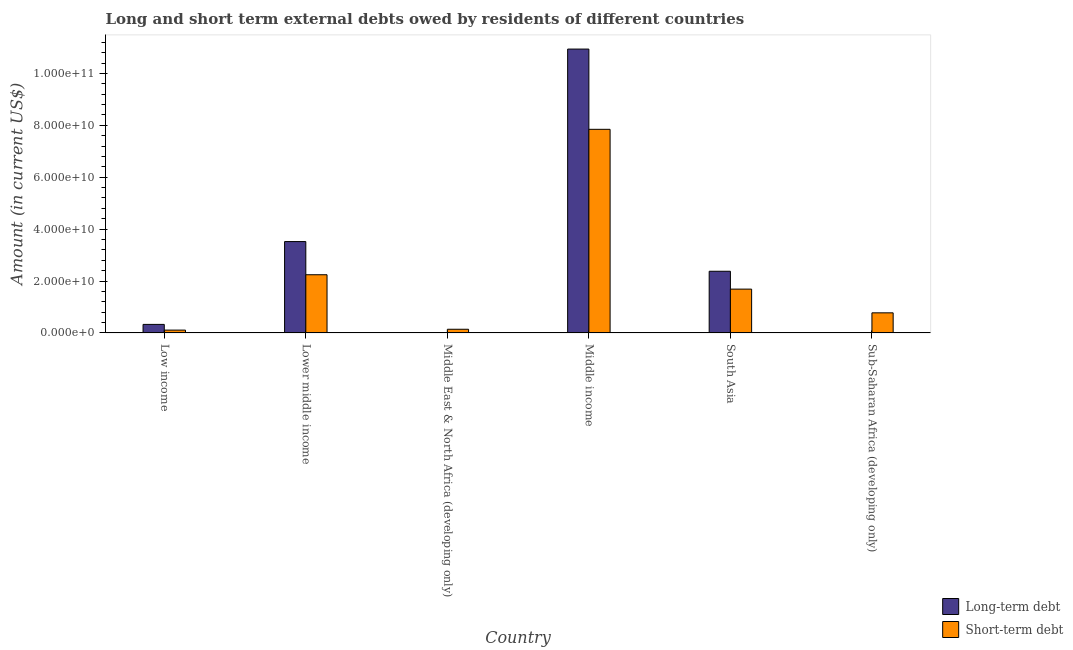How many different coloured bars are there?
Keep it short and to the point. 2. Are the number of bars per tick equal to the number of legend labels?
Offer a terse response. No. Are the number of bars on each tick of the X-axis equal?
Give a very brief answer. No. How many bars are there on the 4th tick from the left?
Ensure brevity in your answer.  2. How many bars are there on the 4th tick from the right?
Ensure brevity in your answer.  1. In how many cases, is the number of bars for a given country not equal to the number of legend labels?
Ensure brevity in your answer.  2. Across all countries, what is the maximum short-term debts owed by residents?
Provide a short and direct response. 7.85e+1. Across all countries, what is the minimum short-term debts owed by residents?
Provide a short and direct response. 1.09e+09. In which country was the long-term debts owed by residents maximum?
Give a very brief answer. Middle income. What is the total short-term debts owed by residents in the graph?
Offer a terse response. 1.28e+11. What is the difference between the short-term debts owed by residents in Low income and that in Lower middle income?
Provide a succinct answer. -2.13e+1. What is the difference between the long-term debts owed by residents in Lower middle income and the short-term debts owed by residents in Low income?
Your answer should be compact. 3.41e+1. What is the average long-term debts owed by residents per country?
Ensure brevity in your answer.  2.86e+1. What is the difference between the long-term debts owed by residents and short-term debts owed by residents in Middle income?
Keep it short and to the point. 3.09e+1. In how many countries, is the short-term debts owed by residents greater than 32000000000 US$?
Your response must be concise. 1. What is the ratio of the short-term debts owed by residents in Low income to that in Sub-Saharan Africa (developing only)?
Keep it short and to the point. 0.14. Is the long-term debts owed by residents in Lower middle income less than that in South Asia?
Provide a short and direct response. No. What is the difference between the highest and the second highest long-term debts owed by residents?
Your response must be concise. 7.42e+1. What is the difference between the highest and the lowest long-term debts owed by residents?
Keep it short and to the point. 1.09e+11. In how many countries, is the short-term debts owed by residents greater than the average short-term debts owed by residents taken over all countries?
Ensure brevity in your answer.  2. How many bars are there?
Ensure brevity in your answer.  10. Are all the bars in the graph horizontal?
Offer a terse response. No. What is the difference between two consecutive major ticks on the Y-axis?
Offer a very short reply. 2.00e+1. Does the graph contain grids?
Provide a succinct answer. No. How many legend labels are there?
Provide a short and direct response. 2. What is the title of the graph?
Offer a terse response. Long and short term external debts owed by residents of different countries. Does "Fraud firms" appear as one of the legend labels in the graph?
Your response must be concise. No. What is the label or title of the Y-axis?
Make the answer very short. Amount (in current US$). What is the Amount (in current US$) of Long-term debt in Low income?
Give a very brief answer. 3.29e+09. What is the Amount (in current US$) in Short-term debt in Low income?
Ensure brevity in your answer.  1.09e+09. What is the Amount (in current US$) of Long-term debt in Lower middle income?
Provide a succinct answer. 3.52e+1. What is the Amount (in current US$) in Short-term debt in Lower middle income?
Your answer should be very brief. 2.24e+1. What is the Amount (in current US$) in Long-term debt in Middle East & North Africa (developing only)?
Offer a very short reply. 0. What is the Amount (in current US$) in Short-term debt in Middle East & North Africa (developing only)?
Your answer should be compact. 1.42e+09. What is the Amount (in current US$) in Long-term debt in Middle income?
Provide a succinct answer. 1.09e+11. What is the Amount (in current US$) of Short-term debt in Middle income?
Provide a succinct answer. 7.85e+1. What is the Amount (in current US$) of Long-term debt in South Asia?
Your response must be concise. 2.38e+1. What is the Amount (in current US$) in Short-term debt in South Asia?
Your response must be concise. 1.69e+1. What is the Amount (in current US$) of Short-term debt in Sub-Saharan Africa (developing only)?
Keep it short and to the point. 7.75e+09. Across all countries, what is the maximum Amount (in current US$) in Long-term debt?
Offer a terse response. 1.09e+11. Across all countries, what is the maximum Amount (in current US$) in Short-term debt?
Make the answer very short. 7.85e+1. Across all countries, what is the minimum Amount (in current US$) in Long-term debt?
Provide a succinct answer. 0. Across all countries, what is the minimum Amount (in current US$) in Short-term debt?
Offer a terse response. 1.09e+09. What is the total Amount (in current US$) in Long-term debt in the graph?
Your answer should be compact. 1.72e+11. What is the total Amount (in current US$) of Short-term debt in the graph?
Ensure brevity in your answer.  1.28e+11. What is the difference between the Amount (in current US$) in Long-term debt in Low income and that in Lower middle income?
Provide a succinct answer. -3.19e+1. What is the difference between the Amount (in current US$) of Short-term debt in Low income and that in Lower middle income?
Your answer should be compact. -2.13e+1. What is the difference between the Amount (in current US$) of Short-term debt in Low income and that in Middle East & North Africa (developing only)?
Offer a very short reply. -3.25e+08. What is the difference between the Amount (in current US$) of Long-term debt in Low income and that in Middle income?
Your answer should be very brief. -1.06e+11. What is the difference between the Amount (in current US$) in Short-term debt in Low income and that in Middle income?
Make the answer very short. -7.74e+1. What is the difference between the Amount (in current US$) in Long-term debt in Low income and that in South Asia?
Keep it short and to the point. -2.05e+1. What is the difference between the Amount (in current US$) of Short-term debt in Low income and that in South Asia?
Offer a terse response. -1.58e+1. What is the difference between the Amount (in current US$) of Short-term debt in Low income and that in Sub-Saharan Africa (developing only)?
Give a very brief answer. -6.65e+09. What is the difference between the Amount (in current US$) in Short-term debt in Lower middle income and that in Middle East & North Africa (developing only)?
Provide a short and direct response. 2.10e+1. What is the difference between the Amount (in current US$) in Long-term debt in Lower middle income and that in Middle income?
Provide a short and direct response. -7.42e+1. What is the difference between the Amount (in current US$) of Short-term debt in Lower middle income and that in Middle income?
Offer a terse response. -5.60e+1. What is the difference between the Amount (in current US$) in Long-term debt in Lower middle income and that in South Asia?
Provide a succinct answer. 1.14e+1. What is the difference between the Amount (in current US$) of Short-term debt in Lower middle income and that in South Asia?
Give a very brief answer. 5.54e+09. What is the difference between the Amount (in current US$) in Short-term debt in Lower middle income and that in Sub-Saharan Africa (developing only)?
Give a very brief answer. 1.47e+1. What is the difference between the Amount (in current US$) of Short-term debt in Middle East & North Africa (developing only) and that in Middle income?
Your answer should be compact. -7.70e+1. What is the difference between the Amount (in current US$) in Short-term debt in Middle East & North Africa (developing only) and that in South Asia?
Offer a terse response. -1.55e+1. What is the difference between the Amount (in current US$) of Short-term debt in Middle East & North Africa (developing only) and that in Sub-Saharan Africa (developing only)?
Give a very brief answer. -6.33e+09. What is the difference between the Amount (in current US$) in Long-term debt in Middle income and that in South Asia?
Your answer should be very brief. 8.56e+1. What is the difference between the Amount (in current US$) of Short-term debt in Middle income and that in South Asia?
Provide a short and direct response. 6.16e+1. What is the difference between the Amount (in current US$) of Short-term debt in Middle income and that in Sub-Saharan Africa (developing only)?
Offer a terse response. 7.07e+1. What is the difference between the Amount (in current US$) of Short-term debt in South Asia and that in Sub-Saharan Africa (developing only)?
Ensure brevity in your answer.  9.14e+09. What is the difference between the Amount (in current US$) in Long-term debt in Low income and the Amount (in current US$) in Short-term debt in Lower middle income?
Your answer should be very brief. -1.91e+1. What is the difference between the Amount (in current US$) of Long-term debt in Low income and the Amount (in current US$) of Short-term debt in Middle East & North Africa (developing only)?
Provide a short and direct response. 1.87e+09. What is the difference between the Amount (in current US$) in Long-term debt in Low income and the Amount (in current US$) in Short-term debt in Middle income?
Offer a very short reply. -7.52e+1. What is the difference between the Amount (in current US$) of Long-term debt in Low income and the Amount (in current US$) of Short-term debt in South Asia?
Offer a terse response. -1.36e+1. What is the difference between the Amount (in current US$) of Long-term debt in Low income and the Amount (in current US$) of Short-term debt in Sub-Saharan Africa (developing only)?
Your answer should be very brief. -4.45e+09. What is the difference between the Amount (in current US$) of Long-term debt in Lower middle income and the Amount (in current US$) of Short-term debt in Middle East & North Africa (developing only)?
Provide a short and direct response. 3.38e+1. What is the difference between the Amount (in current US$) of Long-term debt in Lower middle income and the Amount (in current US$) of Short-term debt in Middle income?
Give a very brief answer. -4.33e+1. What is the difference between the Amount (in current US$) in Long-term debt in Lower middle income and the Amount (in current US$) in Short-term debt in South Asia?
Your answer should be compact. 1.83e+1. What is the difference between the Amount (in current US$) of Long-term debt in Lower middle income and the Amount (in current US$) of Short-term debt in Sub-Saharan Africa (developing only)?
Offer a very short reply. 2.75e+1. What is the difference between the Amount (in current US$) in Long-term debt in Middle income and the Amount (in current US$) in Short-term debt in South Asia?
Your response must be concise. 9.25e+1. What is the difference between the Amount (in current US$) in Long-term debt in Middle income and the Amount (in current US$) in Short-term debt in Sub-Saharan Africa (developing only)?
Give a very brief answer. 1.02e+11. What is the difference between the Amount (in current US$) in Long-term debt in South Asia and the Amount (in current US$) in Short-term debt in Sub-Saharan Africa (developing only)?
Your response must be concise. 1.60e+1. What is the average Amount (in current US$) in Long-term debt per country?
Your answer should be compact. 2.86e+1. What is the average Amount (in current US$) of Short-term debt per country?
Your response must be concise. 2.13e+1. What is the difference between the Amount (in current US$) in Long-term debt and Amount (in current US$) in Short-term debt in Low income?
Offer a very short reply. 2.20e+09. What is the difference between the Amount (in current US$) in Long-term debt and Amount (in current US$) in Short-term debt in Lower middle income?
Keep it short and to the point. 1.28e+1. What is the difference between the Amount (in current US$) of Long-term debt and Amount (in current US$) of Short-term debt in Middle income?
Ensure brevity in your answer.  3.09e+1. What is the difference between the Amount (in current US$) in Long-term debt and Amount (in current US$) in Short-term debt in South Asia?
Ensure brevity in your answer.  6.88e+09. What is the ratio of the Amount (in current US$) of Long-term debt in Low income to that in Lower middle income?
Your response must be concise. 0.09. What is the ratio of the Amount (in current US$) of Short-term debt in Low income to that in Lower middle income?
Make the answer very short. 0.05. What is the ratio of the Amount (in current US$) of Short-term debt in Low income to that in Middle East & North Africa (developing only)?
Your response must be concise. 0.77. What is the ratio of the Amount (in current US$) in Long-term debt in Low income to that in Middle income?
Provide a succinct answer. 0.03. What is the ratio of the Amount (in current US$) in Short-term debt in Low income to that in Middle income?
Offer a terse response. 0.01. What is the ratio of the Amount (in current US$) in Long-term debt in Low income to that in South Asia?
Keep it short and to the point. 0.14. What is the ratio of the Amount (in current US$) of Short-term debt in Low income to that in South Asia?
Give a very brief answer. 0.06. What is the ratio of the Amount (in current US$) in Short-term debt in Low income to that in Sub-Saharan Africa (developing only)?
Give a very brief answer. 0.14. What is the ratio of the Amount (in current US$) in Short-term debt in Lower middle income to that in Middle East & North Africa (developing only)?
Make the answer very short. 15.79. What is the ratio of the Amount (in current US$) of Long-term debt in Lower middle income to that in Middle income?
Your response must be concise. 0.32. What is the ratio of the Amount (in current US$) of Short-term debt in Lower middle income to that in Middle income?
Provide a short and direct response. 0.29. What is the ratio of the Amount (in current US$) in Long-term debt in Lower middle income to that in South Asia?
Your answer should be very brief. 1.48. What is the ratio of the Amount (in current US$) of Short-term debt in Lower middle income to that in South Asia?
Offer a very short reply. 1.33. What is the ratio of the Amount (in current US$) in Short-term debt in Lower middle income to that in Sub-Saharan Africa (developing only)?
Give a very brief answer. 2.9. What is the ratio of the Amount (in current US$) of Short-term debt in Middle East & North Africa (developing only) to that in Middle income?
Ensure brevity in your answer.  0.02. What is the ratio of the Amount (in current US$) of Short-term debt in Middle East & North Africa (developing only) to that in South Asia?
Provide a short and direct response. 0.08. What is the ratio of the Amount (in current US$) of Short-term debt in Middle East & North Africa (developing only) to that in Sub-Saharan Africa (developing only)?
Your response must be concise. 0.18. What is the ratio of the Amount (in current US$) in Long-term debt in Middle income to that in South Asia?
Make the answer very short. 4.6. What is the ratio of the Amount (in current US$) in Short-term debt in Middle income to that in South Asia?
Your answer should be compact. 4.65. What is the ratio of the Amount (in current US$) of Short-term debt in Middle income to that in Sub-Saharan Africa (developing only)?
Your answer should be compact. 10.13. What is the ratio of the Amount (in current US$) of Short-term debt in South Asia to that in Sub-Saharan Africa (developing only)?
Make the answer very short. 2.18. What is the difference between the highest and the second highest Amount (in current US$) of Long-term debt?
Your response must be concise. 7.42e+1. What is the difference between the highest and the second highest Amount (in current US$) of Short-term debt?
Offer a terse response. 5.60e+1. What is the difference between the highest and the lowest Amount (in current US$) of Long-term debt?
Offer a very short reply. 1.09e+11. What is the difference between the highest and the lowest Amount (in current US$) in Short-term debt?
Offer a very short reply. 7.74e+1. 